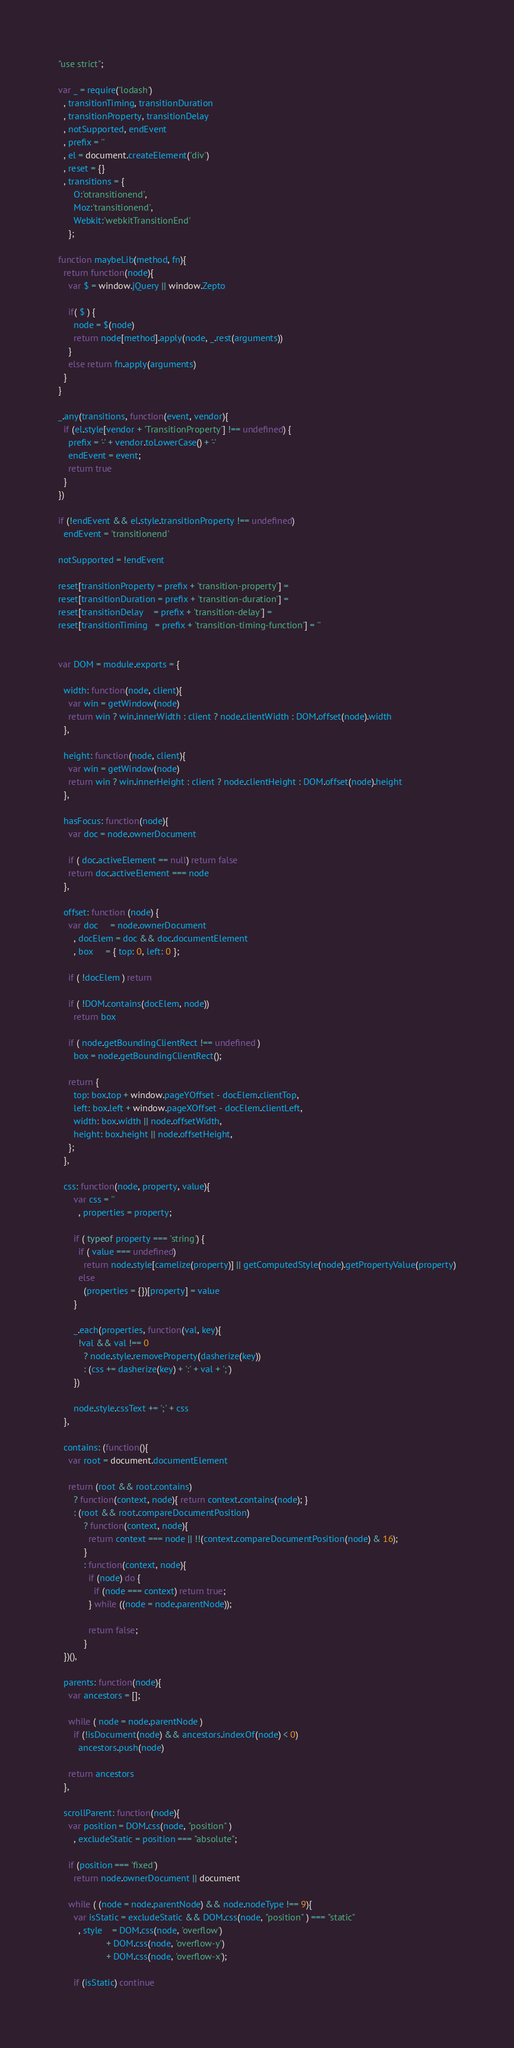Convert code to text. <code><loc_0><loc_0><loc_500><loc_500><_JavaScript_>"use strict";

var _ = require('lodash')
  , transitionTiming, transitionDuration
  , transitionProperty, transitionDelay
  , notSupported, endEvent
  , prefix = ''
  , el = document.createElement('div')
  , reset = {}
  , transitions = {
      O:'otransitionend',
      Moz:'transitionend',
      Webkit:'webkitTransitionEnd'
    };

function maybeLib(method, fn){
  return function(node){
    var $ = window.jQuery || window.Zepto

    if( $ ) {
      node = $(node)
      return node[method].apply(node, _.rest(arguments))
    }
    else return fn.apply(arguments)
  }
}

_.any(transitions, function(event, vendor){
  if (el.style[vendor + 'TransitionProperty'] !== undefined) {
    prefix = '-' + vendor.toLowerCase() + '-'
    endEvent = event;
    return true
  }
})

if (!endEvent && el.style.transitionProperty !== undefined)
  endEvent = 'transitionend'

notSupported = !endEvent

reset[transitionProperty = prefix + 'transition-property'] =
reset[transitionDuration = prefix + 'transition-duration'] =
reset[transitionDelay    = prefix + 'transition-delay'] =
reset[transitionTiming   = prefix + 'transition-timing-function'] = ''


var DOM = module.exports = {

  width: function(node, client){
    var win = getWindow(node)
    return win ? win.innerWidth : client ? node.clientWidth : DOM.offset(node).width
  },

  height: function(node, client){
    var win = getWindow(node)
    return win ? win.innerHeight : client ? node.clientHeight : DOM.offset(node).height
  },

  hasFocus: function(node){
    var doc = node.ownerDocument

    if ( doc.activeElement == null) return false
    return doc.activeElement === node
  },

  offset: function (node) {
    var doc     = node.ownerDocument
      , docElem = doc && doc.documentElement
      , box     = { top: 0, left: 0 };

    if ( !docElem ) return

    if ( !DOM.contains(docElem, node))
      return box

    if ( node.getBoundingClientRect !== undefined )
      box = node.getBoundingClientRect();

    return {
      top: box.top + window.pageYOffset - docElem.clientTop,
      left: box.left + window.pageXOffset - docElem.clientLeft,
      width: box.width || node.offsetWidth,
      height: box.height || node.offsetHeight,
    };
  },

  css: function(node, property, value){
      var css = ''
        , properties = property;

      if ( typeof property === 'string') {
        if ( value === undefined)
          return node.style[camelize(property)] || getComputedStyle(node).getPropertyValue(property)
        else
          (properties = {})[property] = value
      }

      _.each(properties, function(val, key){
        !val && val !== 0
          ? node.style.removeProperty(dasherize(key))
          : (css += dasherize(key) + ':' + val + ';')
      })

      node.style.cssText += ';' + css
  },

  contains: (function(){
    var root = document.documentElement

    return (root && root.contains)
      ? function(context, node){ return context.contains(node); }
      : (root && root.compareDocumentPosition)
          ? function(context, node){
            return context === node || !!(context.compareDocumentPosition(node) & 16);
          }
          : function(context, node){
            if (node) do {
              if (node === context) return true;
            } while ((node = node.parentNode));

            return false;
          }
  })(),

  parents: function(node){
    var ancestors = [];

    while ( node = node.parentNode )
      if (!isDocument(node) && ancestors.indexOf(node) < 0) 
        ancestors.push(node)

    return ancestors
  },

  scrollParent: function(node){
    var position = DOM.css(node, "position" )
      , excludeStatic = position === "absolute";

    if (position === 'fixed') 
      return node.ownerDocument || document

    while ( (node = node.parentNode) && node.nodeType !== 9){
      var isStatic = excludeStatic && DOM.css(node, "position" ) === "static"
        , style    = DOM.css(node, 'overflow') 
                   + DOM.css(node, 'overflow-y') 
                   + DOM.css(node, 'overflow-x');

      if (isStatic) continue</code> 